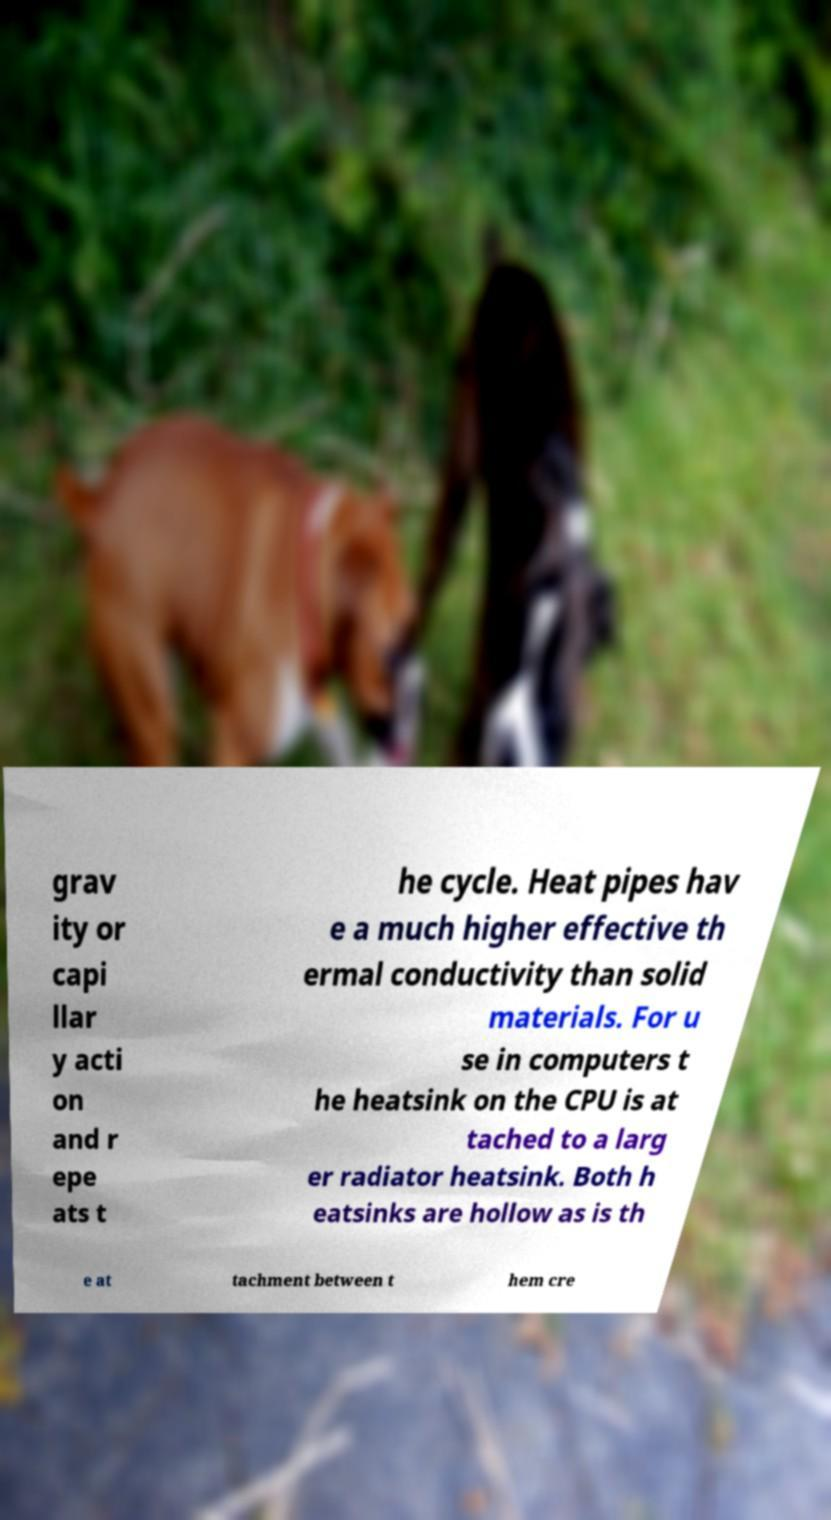There's text embedded in this image that I need extracted. Can you transcribe it verbatim? grav ity or capi llar y acti on and r epe ats t he cycle. Heat pipes hav e a much higher effective th ermal conductivity than solid materials. For u se in computers t he heatsink on the CPU is at tached to a larg er radiator heatsink. Both h eatsinks are hollow as is th e at tachment between t hem cre 